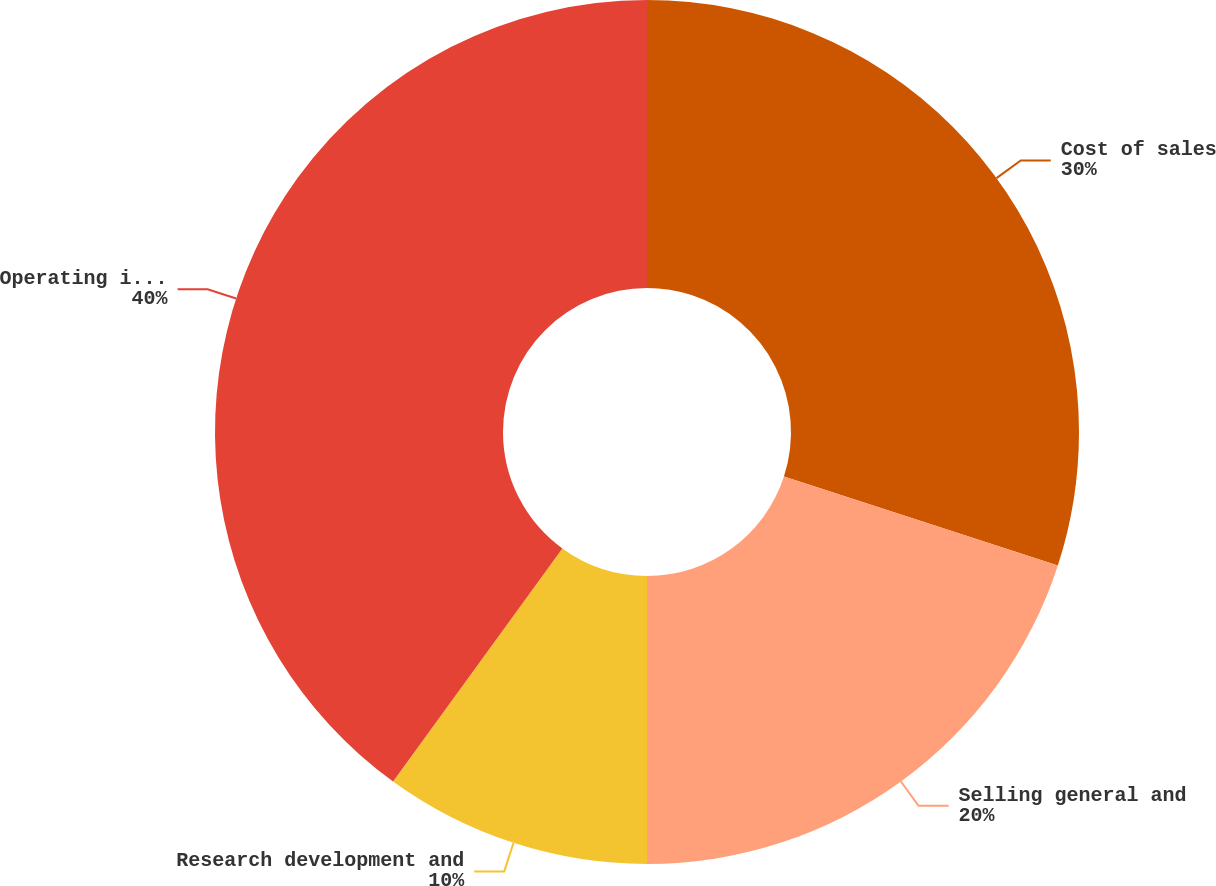<chart> <loc_0><loc_0><loc_500><loc_500><pie_chart><fcel>Cost of sales<fcel>Selling general and<fcel>Research development and<fcel>Operating income<nl><fcel>30.0%<fcel>20.0%<fcel>10.0%<fcel>40.0%<nl></chart> 